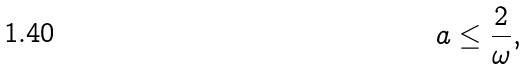Convert formula to latex. <formula><loc_0><loc_0><loc_500><loc_500>a \leq \frac { 2 } { \omega } ,</formula> 